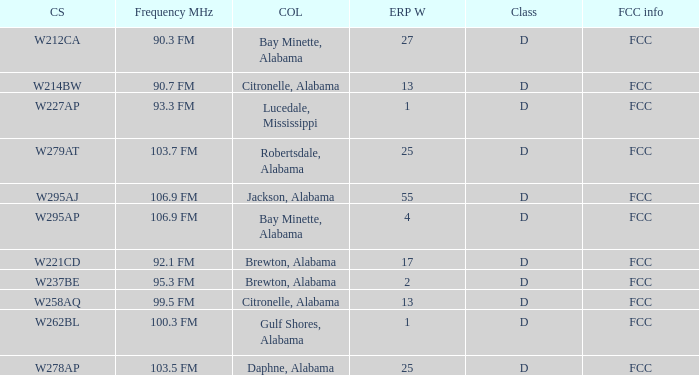Name the call sign for ERP W of 27 W212CA. 